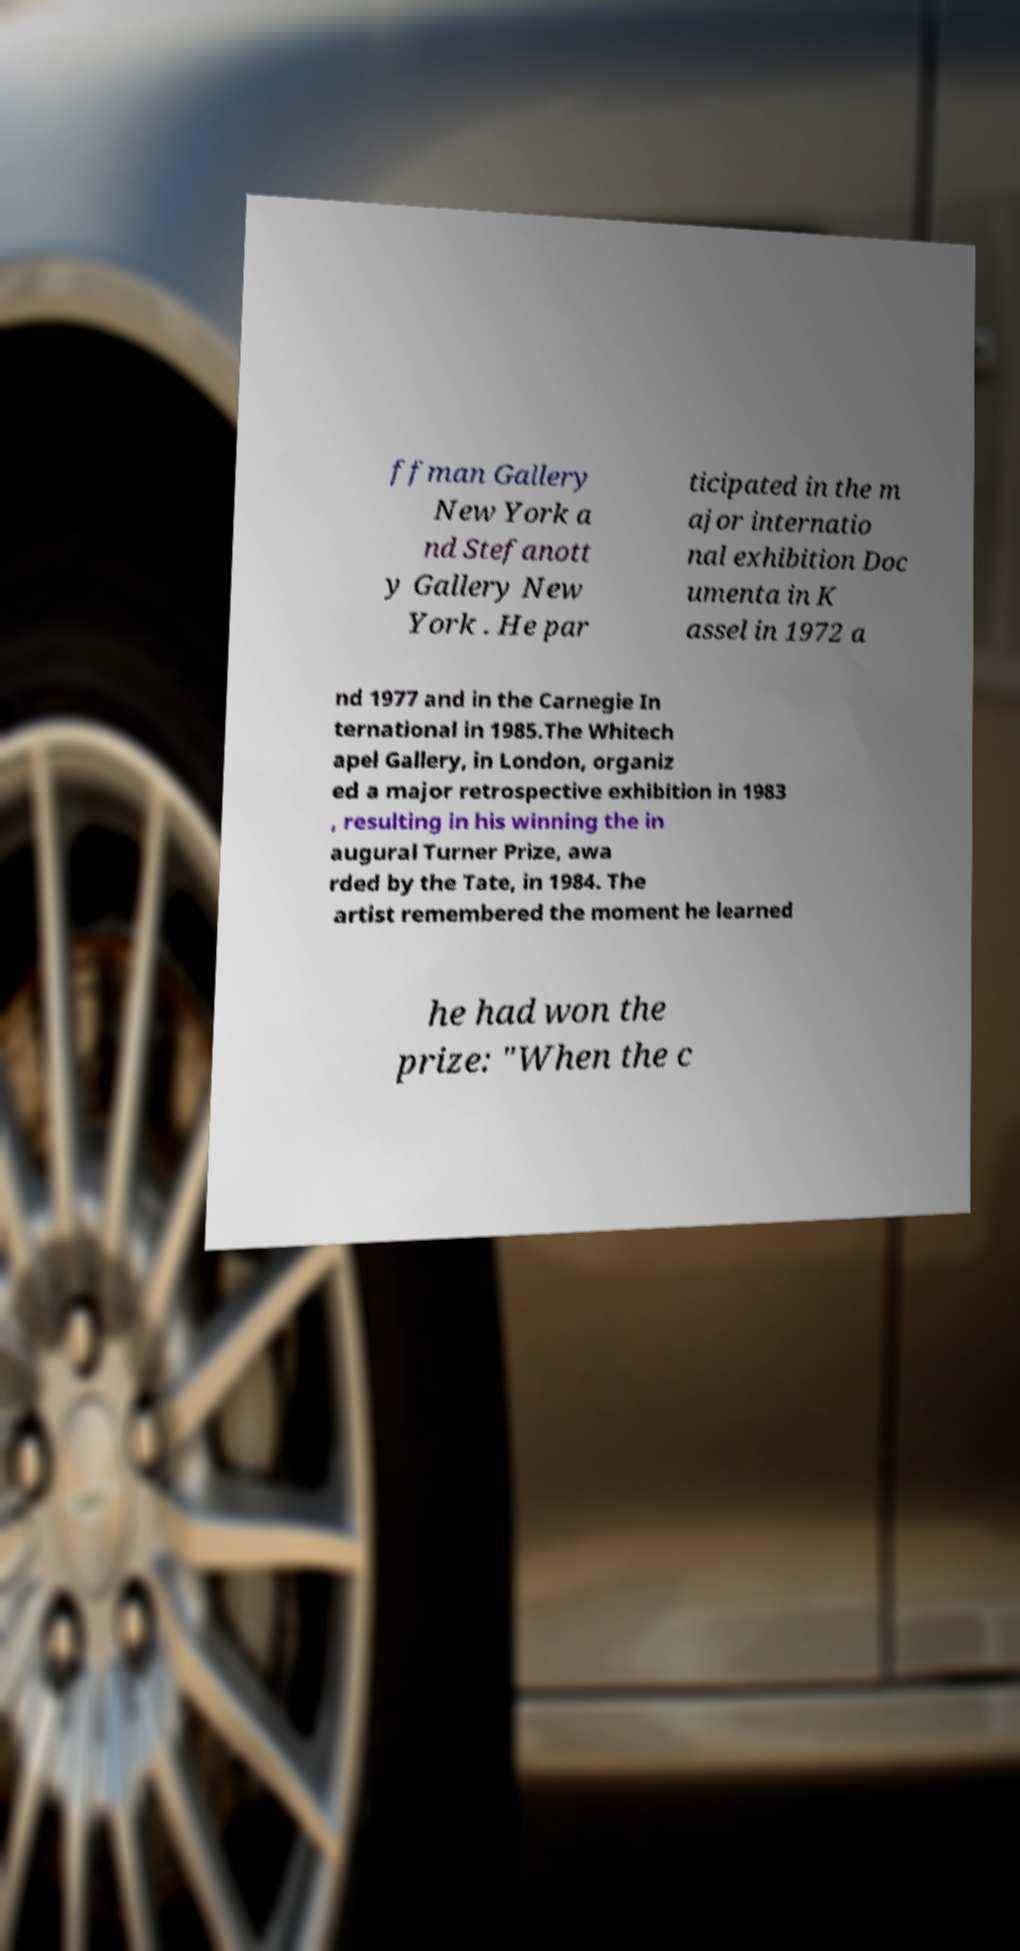Please identify and transcribe the text found in this image. ffman Gallery New York a nd Stefanott y Gallery New York . He par ticipated in the m ajor internatio nal exhibition Doc umenta in K assel in 1972 a nd 1977 and in the Carnegie In ternational in 1985.The Whitech apel Gallery, in London, organiz ed a major retrospective exhibition in 1983 , resulting in his winning the in augural Turner Prize, awa rded by the Tate, in 1984. The artist remembered the moment he learned he had won the prize: "When the c 